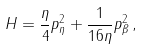Convert formula to latex. <formula><loc_0><loc_0><loc_500><loc_500>H = \frac { \eta } { 4 } p _ { \eta } ^ { 2 } + \frac { 1 } { 1 6 \eta } p _ { \beta } ^ { 2 } \, ,</formula> 